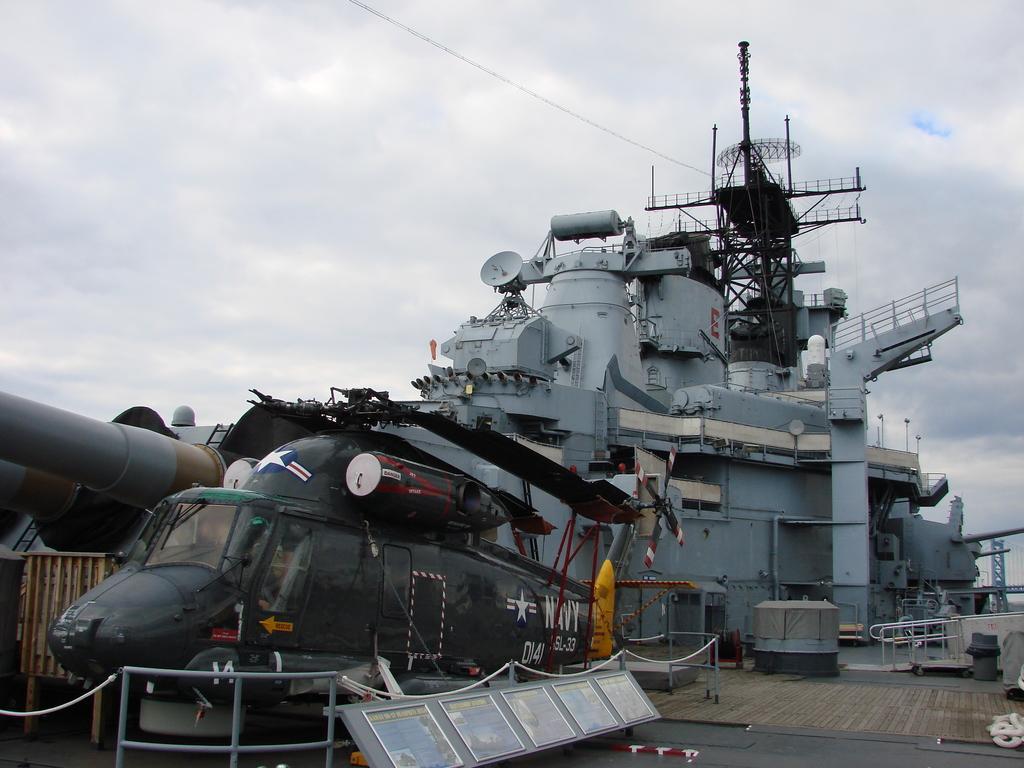How would you summarize this image in a sentence or two? In the image there is a ship in the background with a helicopter in front of it and above its sky with clouds. 